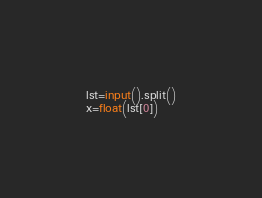<code> <loc_0><loc_0><loc_500><loc_500><_Python_>lst=input().split()
x=float(lst[0])

</code> 